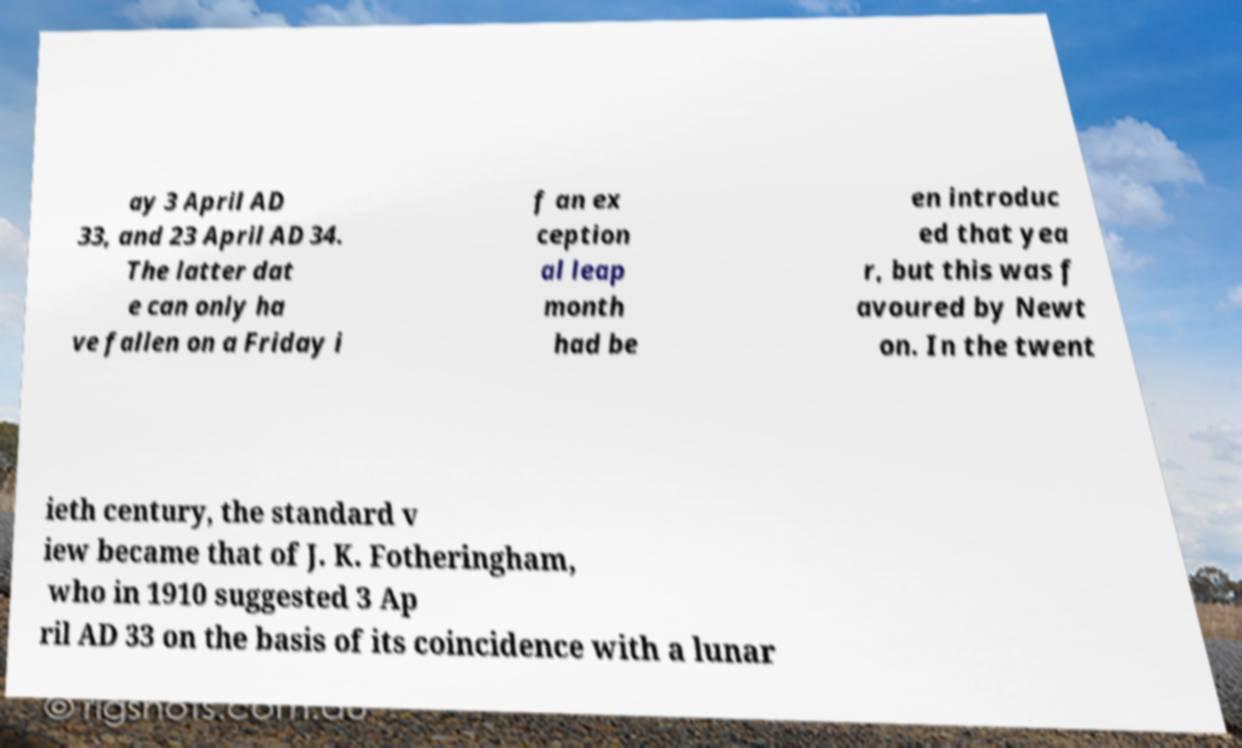Please identify and transcribe the text found in this image. ay 3 April AD 33, and 23 April AD 34. The latter dat e can only ha ve fallen on a Friday i f an ex ception al leap month had be en introduc ed that yea r, but this was f avoured by Newt on. In the twent ieth century, the standard v iew became that of J. K. Fotheringham, who in 1910 suggested 3 Ap ril AD 33 on the basis of its coincidence with a lunar 